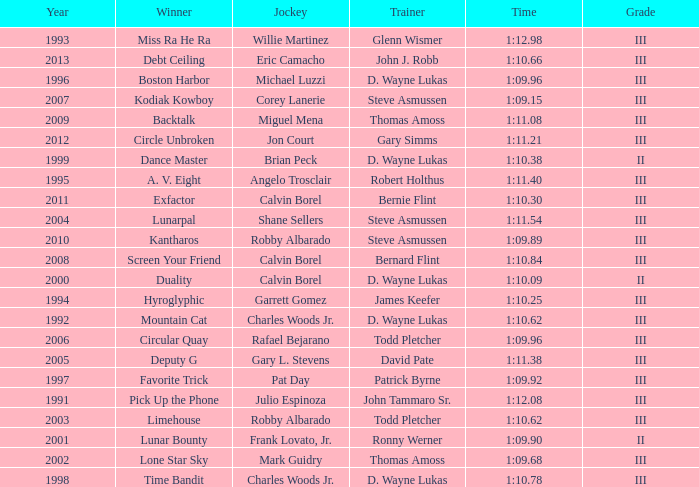Parse the table in full. {'header': ['Year', 'Winner', 'Jockey', 'Trainer', 'Time', 'Grade'], 'rows': [['1993', 'Miss Ra He Ra', 'Willie Martinez', 'Glenn Wismer', '1:12.98', 'III'], ['2013', 'Debt Ceiling', 'Eric Camacho', 'John J. Robb', '1:10.66', 'III'], ['1996', 'Boston Harbor', 'Michael Luzzi', 'D. Wayne Lukas', '1:09.96', 'III'], ['2007', 'Kodiak Kowboy', 'Corey Lanerie', 'Steve Asmussen', '1:09.15', 'III'], ['2009', 'Backtalk', 'Miguel Mena', 'Thomas Amoss', '1:11.08', 'III'], ['2012', 'Circle Unbroken', 'Jon Court', 'Gary Simms', '1:11.21', 'III'], ['1999', 'Dance Master', 'Brian Peck', 'D. Wayne Lukas', '1:10.38', 'II'], ['1995', 'A. V. Eight', 'Angelo Trosclair', 'Robert Holthus', '1:11.40', 'III'], ['2011', 'Exfactor', 'Calvin Borel', 'Bernie Flint', '1:10.30', 'III'], ['2004', 'Lunarpal', 'Shane Sellers', 'Steve Asmussen', '1:11.54', 'III'], ['2010', 'Kantharos', 'Robby Albarado', 'Steve Asmussen', '1:09.89', 'III'], ['2008', 'Screen Your Friend', 'Calvin Borel', 'Bernard Flint', '1:10.84', 'III'], ['2000', 'Duality', 'Calvin Borel', 'D. Wayne Lukas', '1:10.09', 'II'], ['1994', 'Hyroglyphic', 'Garrett Gomez', 'James Keefer', '1:10.25', 'III'], ['1992', 'Mountain Cat', 'Charles Woods Jr.', 'D. Wayne Lukas', '1:10.62', 'III'], ['2006', 'Circular Quay', 'Rafael Bejarano', 'Todd Pletcher', '1:09.96', 'III'], ['2005', 'Deputy G', 'Gary L. Stevens', 'David Pate', '1:11.38', 'III'], ['1997', 'Favorite Trick', 'Pat Day', 'Patrick Byrne', '1:09.92', 'III'], ['1991', 'Pick Up the Phone', 'Julio Espinoza', 'John Tammaro Sr.', '1:12.08', 'III'], ['2003', 'Limehouse', 'Robby Albarado', 'Todd Pletcher', '1:10.62', 'III'], ['2001', 'Lunar Bounty', 'Frank Lovato, Jr.', 'Ronny Werner', '1:09.90', 'II'], ['2002', 'Lone Star Sky', 'Mark Guidry', 'Thomas Amoss', '1:09.68', 'III'], ['1998', 'Time Bandit', 'Charles Woods Jr.', 'D. Wayne Lukas', '1:10.78', 'III']]} Which trainer won the hyroglyphic in a year that was before 2010? James Keefer. 